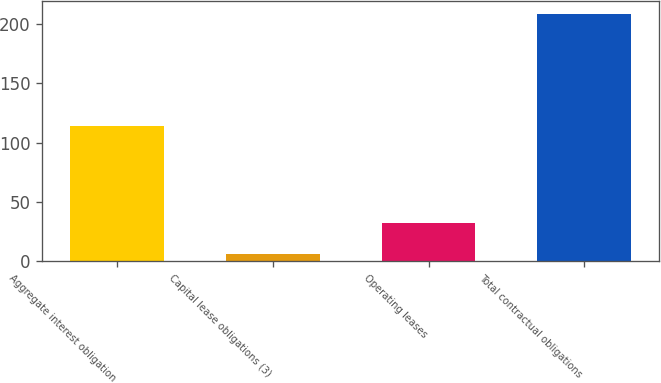Convert chart to OTSL. <chart><loc_0><loc_0><loc_500><loc_500><bar_chart><fcel>Aggregate interest obligation<fcel>Capital lease obligations (3)<fcel>Operating leases<fcel>Total contractual obligations<nl><fcel>114<fcel>6<fcel>32<fcel>209<nl></chart> 